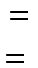<formula> <loc_0><loc_0><loc_500><loc_500>\begin{matrix} = \\ = \ \end{matrix}</formula> 